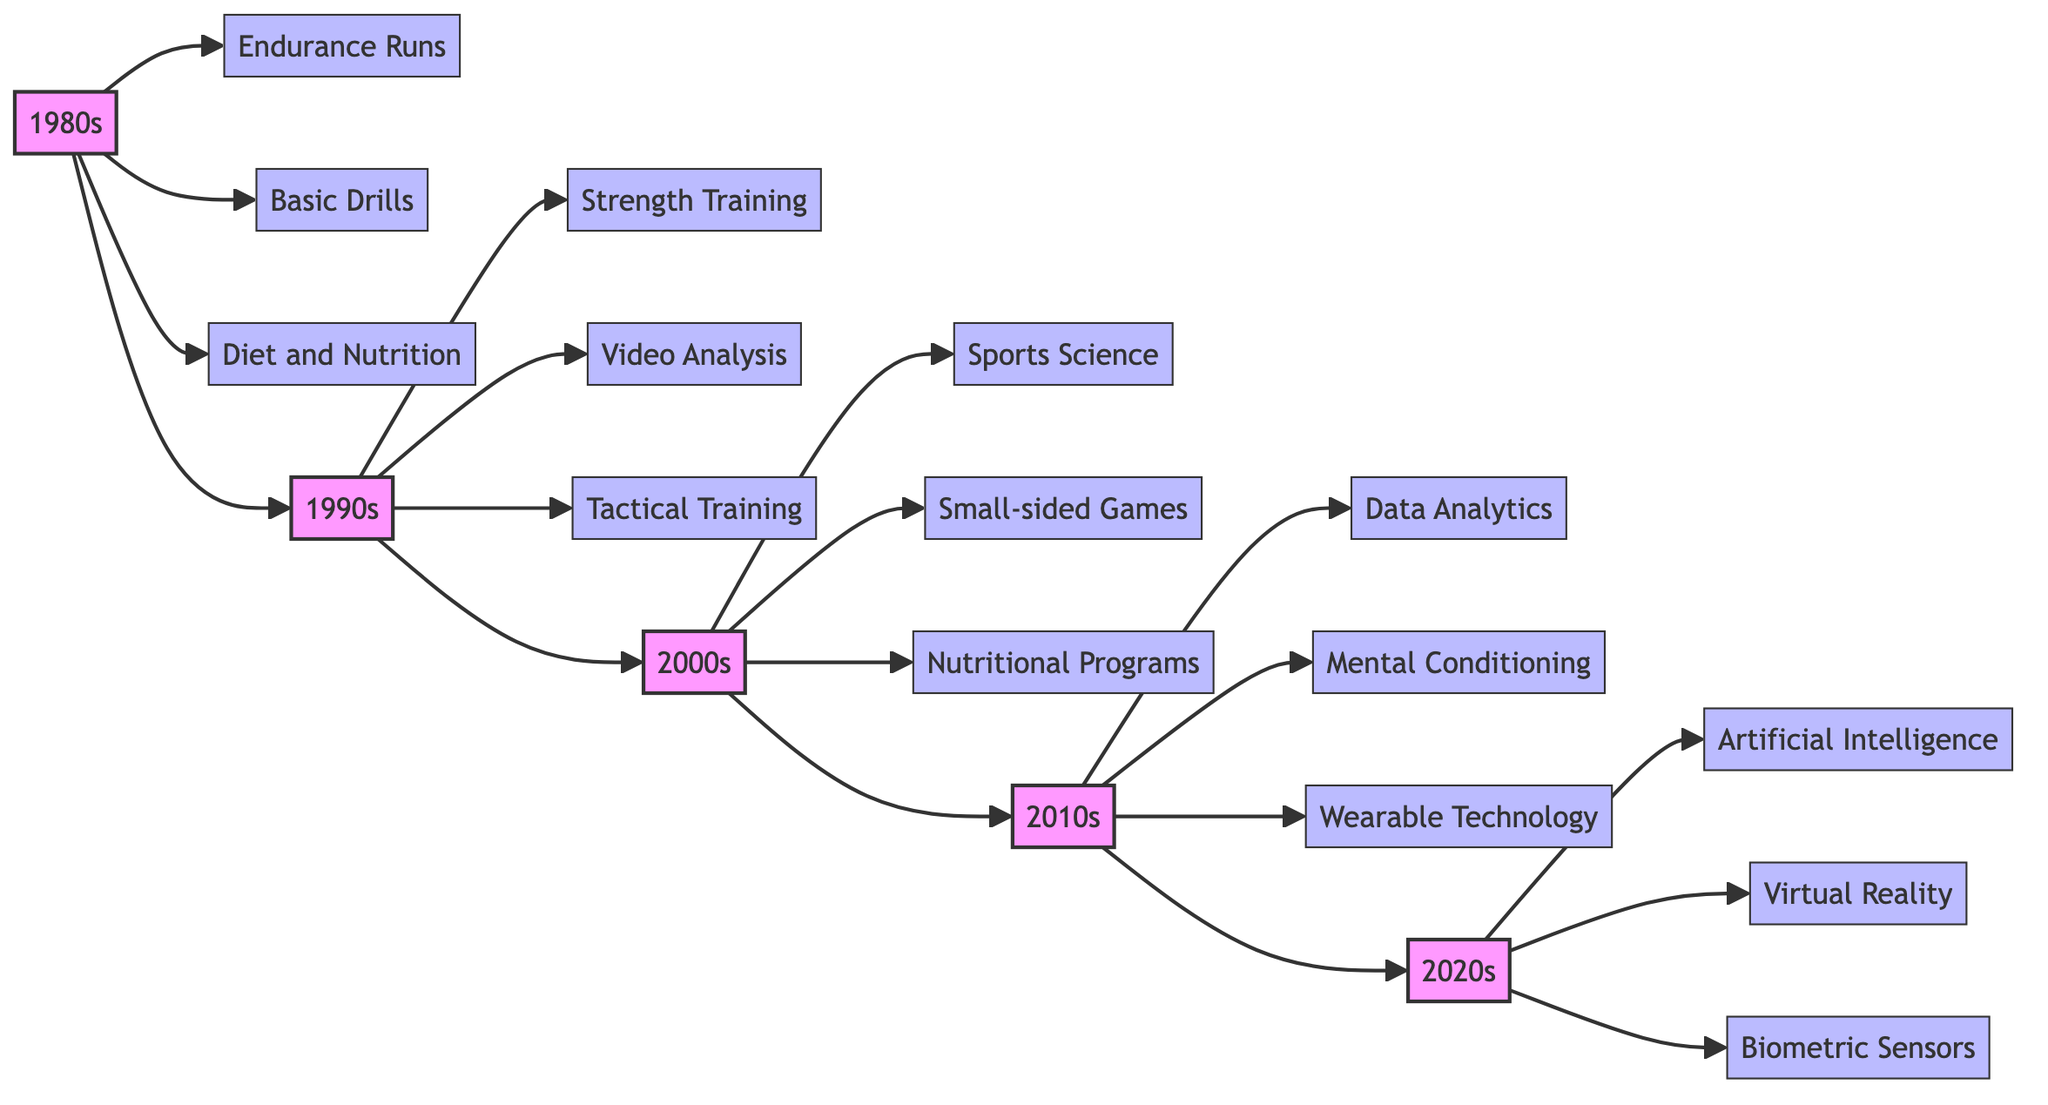What training technique is associated with the 1990s? The 1990s have multiple training techniques listed, such as Strength Training, Video Analysis, and Tactical Training; any of these would be correct. For example, Strength Training is specifically noted.
Answer: Strength Training How many training techniques are listed for the 2000s? Upon examining the 2000s section, there are three techniques shown: Sports Science, Small-sided Games, and Nutritional Programs. Hence, the count is three.
Answer: 3 What is one training technique introduced in the 2010s? The 2010s section details several techniques, such as Data Analytics, Mental Conditioning, and Wearable Technology; one of these is Data Analytics.
Answer: Data Analytics Which decade saw the introduction of Artificial Intelligence in training? Looking at the 2020s section, it specifically mentions Artificial Intelligence as one of the training techniques introduced in this period. Thus, the decade is the 2020s.
Answer: 2020s What type of sensor is mentioned in the 2020s training techniques? The 2020s section includes Biometric Sensors as one of the advanced training techniques noted for this decade.
Answer: Biometric Sensors How does the training techniques in the 1980s differ from those in the 2010s? The 1980s primarily focus on traditional endurance and basic drills, whereas the 2010s include modern approaches like Data Analytics and Wearable Technology, indicating a shift towards data-driven training methods.
Answer: Traditional vs. Modern Identify a technique that emphasizes psychological training from the 2010s. The 2010s section explicitly mentions Mental Conditioning, which focuses on psychological aspects, as one of the newer techniques introduced during this decade.
Answer: Mental Conditioning What training focus increased in the 1990s compared to the 1980s? The 1990s introduced Tactical Training, showing an increased emphasis on team formations, contrasting with the individual focus mainly seen in the 1980s training methods.
Answer: Tactical Training 